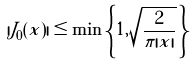Convert formula to latex. <formula><loc_0><loc_0><loc_500><loc_500>| J _ { 0 } ( x ) | \leq \min \left \{ 1 , \sqrt { \frac { 2 } { \pi | x | } } \, \right \}</formula> 